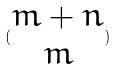<formula> <loc_0><loc_0><loc_500><loc_500>( \begin{matrix} m + n \\ m \end{matrix} )</formula> 